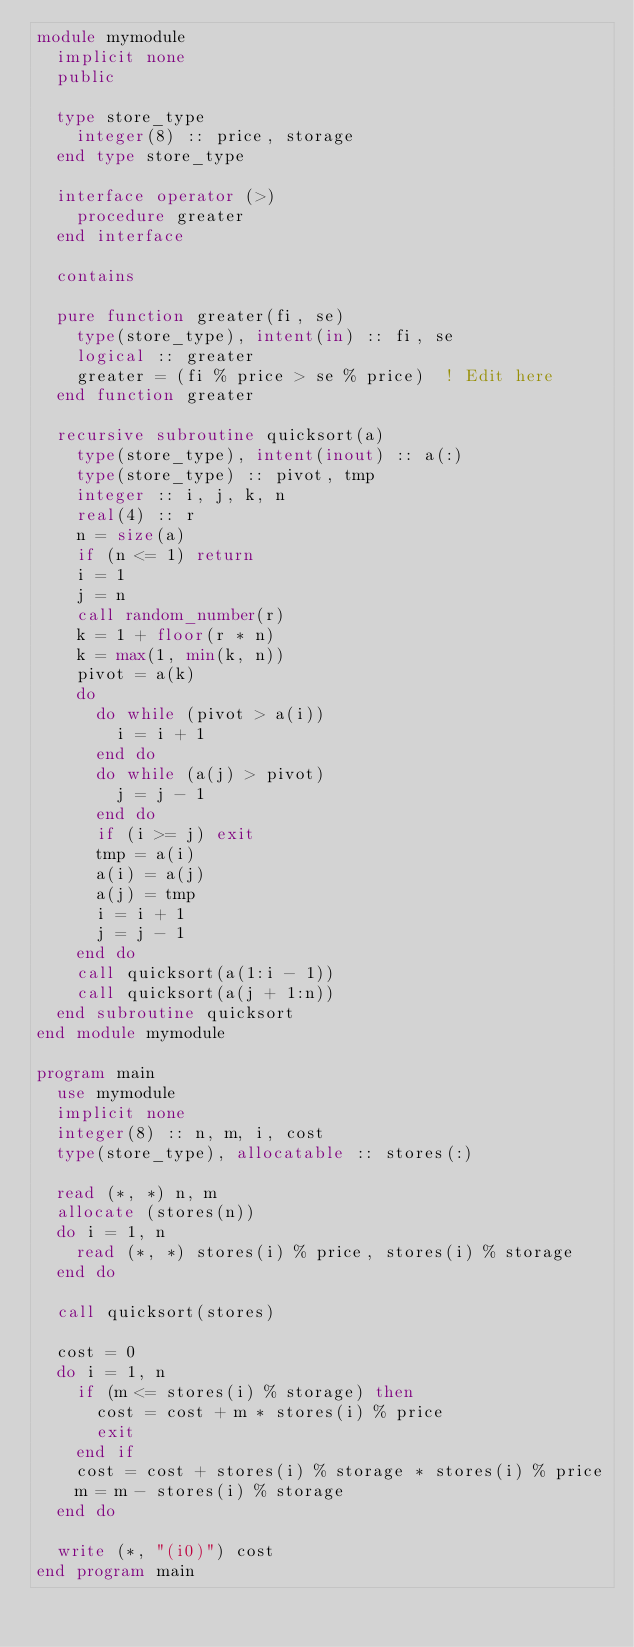<code> <loc_0><loc_0><loc_500><loc_500><_FORTRAN_>module mymodule
  implicit none
  public

  type store_type
    integer(8) :: price, storage
  end type store_type

  interface operator (>)
    procedure greater
  end interface

  contains

  pure function greater(fi, se)
    type(store_type), intent(in) :: fi, se
    logical :: greater
    greater = (fi % price > se % price)  ! Edit here
  end function greater

  recursive subroutine quicksort(a)
    type(store_type), intent(inout) :: a(:)
    type(store_type) :: pivot, tmp
    integer :: i, j, k, n
    real(4) :: r
    n = size(a)
    if (n <= 1) return
    i = 1
    j = n
    call random_number(r)
    k = 1 + floor(r * n)
    k = max(1, min(k, n))
    pivot = a(k)
    do
      do while (pivot > a(i))
        i = i + 1
      end do
      do while (a(j) > pivot)
        j = j - 1
      end do
      if (i >= j) exit
      tmp = a(i)
      a(i) = a(j)
      a(j) = tmp
      i = i + 1
      j = j - 1
    end do
    call quicksort(a(1:i - 1))
    call quicksort(a(j + 1:n))
  end subroutine quicksort
end module mymodule

program main
  use mymodule
  implicit none
  integer(8) :: n, m, i, cost
  type(store_type), allocatable :: stores(:)

  read (*, *) n, m
  allocate (stores(n))
  do i = 1, n
    read (*, *) stores(i) % price, stores(i) % storage
  end do

  call quicksort(stores)

  cost = 0
  do i = 1, n
    if (m <= stores(i) % storage) then
      cost = cost + m * stores(i) % price
      exit
    end if
    cost = cost + stores(i) % storage * stores(i) % price
    m = m - stores(i) % storage
  end do

  write (*, "(i0)") cost
end program main
</code> 